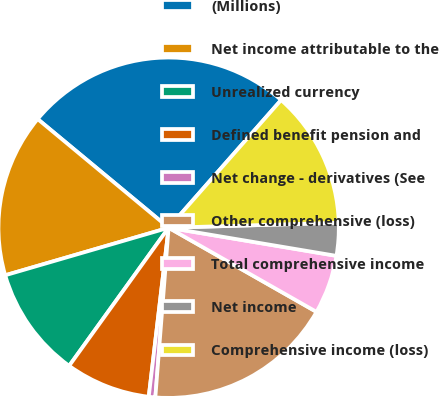Convert chart. <chart><loc_0><loc_0><loc_500><loc_500><pie_chart><fcel>(Millions)<fcel>Net income attributable to the<fcel>Unrealized currency<fcel>Defined benefit pension and<fcel>Net change - derivatives (See<fcel>Other comprehensive (loss)<fcel>Total comprehensive income<fcel>Net income<fcel>Comprehensive income (loss)<nl><fcel>25.47%<fcel>15.53%<fcel>10.56%<fcel>8.07%<fcel>0.62%<fcel>18.01%<fcel>5.59%<fcel>3.11%<fcel>13.04%<nl></chart> 